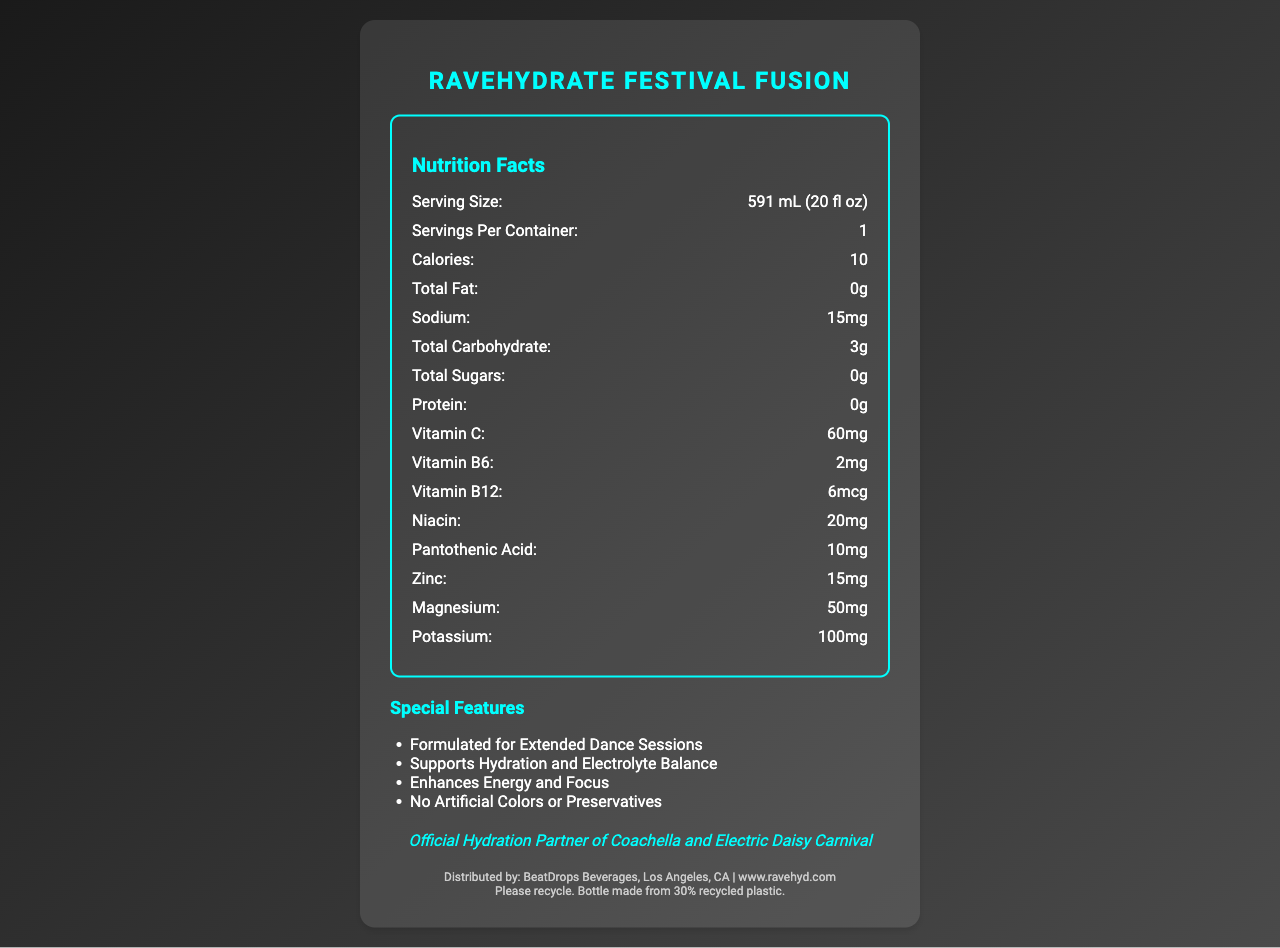what is the serving size? The serving size specification is stated as "591 mL (20 fl oz)" under the nutrition facts section.
Answer: 591 mL (20 fl oz) how many calories are in one serving? The calories per serving are listed as "10" in the nutrition facts section.
Answer: 10 what is the total carbohydrate content? The total carbohydrate content is mentioned as "3g" in the nutrition facts section.
Answer: 3g what is the vitamin C content per serving? The vitamin C content is specified as "60mg" in the nutrition facts section.
Answer: 60mg which of the following special features is NOT listed for RaveHydrate Festival Fusion?
A. Enhances Energy and Focus
B. Contains Protein
C. Formulated for Extended Dance Sessions The special features listed are: "Formulated for Extended Dance Sessions," "Supports Hydration and Electrolyte Balance," "Enhances Energy and Focus," and "No Artificial Colors or Preservatives." There is no mention of containing protein.
Answer: B. Contains Protein what flavor is RaveHydrate Festival Fusion? The flavor is stated as "Electric Lemon-Lime."
Answer: Electric Lemon-Lime is there any fat content in RaveHydrate Festival Fusion? The nutrition facts specify that the total fat content is "0g," indicating there is no fat.
Answer: No for how many servings is the nutrition information given? The nutrition facts indicate "Servings Per Container: 1," meaning the information given is for one serving.
Answer: 1 which vitamins and minerals are included in RaveHydrate Festival Fusion?
I. Vitamin C
II. Calcium
III. Vitamin B6
IV. Magnesium
Choose the correct combination:
A. I and III
B. I, III, and IV
C. II and IV The nutrition facts list Vitamin C, Vitamin B6, and Magnesium among the contents, but not Calcium.
Answer: B. I, III, and IV is RaveHydrate produced in a facility that processes allergens? The allergen information specifies that it is "Produced in a facility that processes soy and tree nuts."
Answer: Yes summarize the main idea of the document. The document thoroughly details the nutrition facts, special features, promotional claims, and allergen warnings for the product named RaveHydrate Festival Fusion.
Answer: The document provides the nutritional information for RaveHydrate Festival Fusion, a vitamin-enhanced water bottle marketed for music festivals. It includes serving size, calories, various vitamins and mineral contents, special features, allergen information, distributor details, and promotional text. can you determine the price of RaveHydrate Festival Fusion from the document? The document does not provide any information about the price of RaveHydrate Festival Fusion. The focus is primarily on nutritional content, special features, and general product information.
Answer: Cannot be determined 